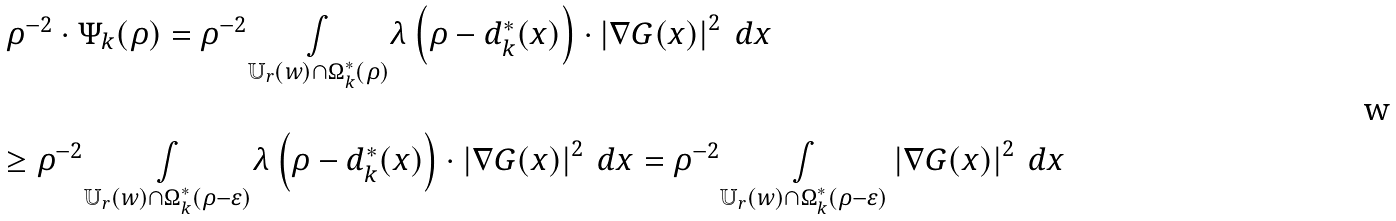Convert formula to latex. <formula><loc_0><loc_0><loc_500><loc_500>\begin{array} { l } \rho ^ { - 2 } \cdot \Psi _ { k } ( \rho ) = \rho ^ { - 2 } \underset { \mathbb { U } _ { r } ( w ) \cap \Omega ^ { \ast } _ { k } ( \rho ) } { \int } \lambda \left ( \rho - d ^ { \ast } _ { k } ( x ) \right ) \cdot \left | \nabla G ( x ) \right | ^ { 2 } \text { } d x \\ \\ \geq \rho ^ { - 2 } \underset { \mathbb { U } _ { r } ( w ) \cap \Omega ^ { \ast } _ { k } ( \rho - \varepsilon ) } { \int } \lambda \left ( \rho - d ^ { \ast } _ { k } ( x ) \right ) \cdot \left | \nabla G ( x ) \right | ^ { 2 } \text { } d x = \rho ^ { - 2 } \underset { \mathbb { U } _ { r } ( w ) \cap \Omega ^ { \ast } _ { k } ( \rho - \varepsilon ) } { \int } \left | \nabla G ( x ) \right | ^ { 2 } \text { } d x \end{array}</formula> 